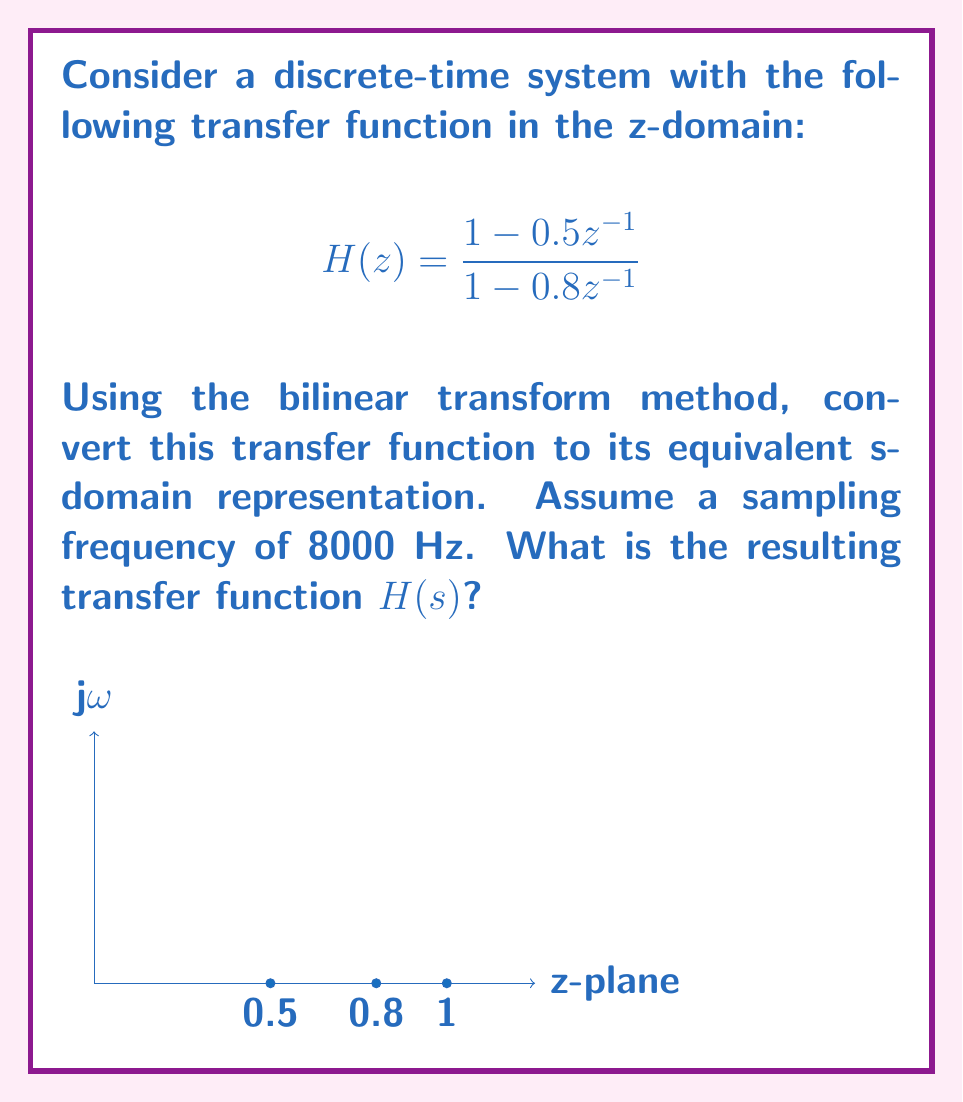Help me with this question. To convert the z-domain transfer function to the s-domain using the bilinear transform, we follow these steps:

1) The bilinear transform is defined as:

   $$z = \frac{1 + \frac{s}{2f_s}}{1 - \frac{s}{2f_s}}$$

   where $f_s$ is the sampling frequency.

2) Substitute this expression for z in the original transfer function:

   $$H(s) = \frac{1 - 0.5(\frac{1 + \frac{s}{2f_s}}{1 - \frac{s}{2f_s}})^{-1}}{1 - 0.8(\frac{1 + \frac{s}{2f_s}}{1 - \frac{s}{2f_s}})^{-1}}$$

3) Simplify the expression:

   $$H(s) = \frac{1 - 0.5(\frac{1 - \frac{s}{2f_s}}{1 + \frac{s}{2f_s}})}{1 - 0.8(\frac{1 - \frac{s}{2f_s}}{1 + \frac{s}{2f_s}})}$$

4) Multiply both numerator and denominator by $(1 + \frac{s}{2f_s})$:

   $$H(s) = \frac{(1 + \frac{s}{2f_s}) - 0.5(1 - \frac{s}{2f_s})}{(1 + \frac{s}{2f_s}) - 0.8(1 - \frac{s}{2f_s})}$$

5) Expand the terms:

   $$H(s) = \frac{1 + \frac{s}{2f_s} - 0.5 + 0.5\frac{s}{2f_s}}{1 + \frac{s}{2f_s} - 0.8 + 0.8\frac{s}{2f_s}}$$

6) Combine like terms:

   $$H(s) = \frac{0.5 + 0.75\frac{s}{2f_s}}{0.2 + 0.9\frac{s}{2f_s}}$$

7) Substitute $f_s = 8000$ Hz:

   $$H(s) = \frac{0.5 + 0.75\frac{s}{16000}}{0.2 + 0.9\frac{s}{16000}}$$

8) Multiply numerator and denominator by 16000:

   $$H(s) = \frac{8000 + 750s}{3200 + 900s}$$

This is the final s-domain transfer function.
Answer: $$H(s) = \frac{8000 + 750s}{3200 + 900s}$$ 